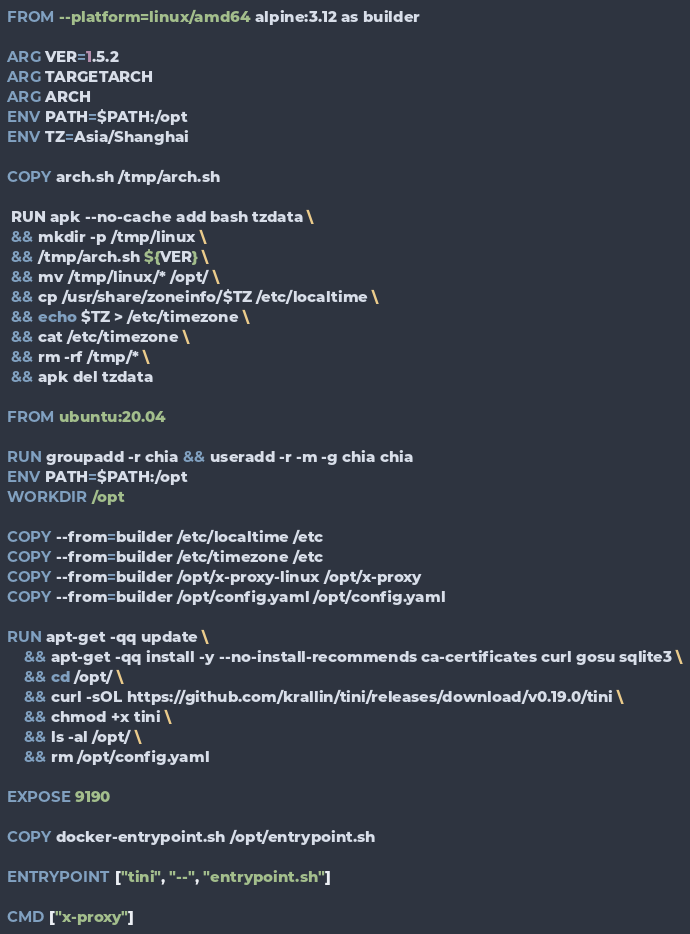Convert code to text. <code><loc_0><loc_0><loc_500><loc_500><_Dockerfile_>FROM --platform=linux/amd64 alpine:3.12 as builder

ARG VER=1.5.2
ARG TARGETARCH
ARG ARCH
ENV PATH=$PATH:/opt
ENV TZ=Asia/Shanghai

COPY arch.sh /tmp/arch.sh

 RUN apk --no-cache add bash tzdata \
 && mkdir -p /tmp/linux \
 && /tmp/arch.sh ${VER} \
 && mv /tmp/linux/* /opt/ \
 && cp /usr/share/zoneinfo/$TZ /etc/localtime \
 && echo $TZ > /etc/timezone \
 && cat /etc/timezone \
 && rm -rf /tmp/* \
 && apk del tzdata

FROM ubuntu:20.04

RUN groupadd -r chia && useradd -r -m -g chia chia
ENV PATH=$PATH:/opt
WORKDIR /opt

COPY --from=builder /etc/localtime /etc
COPY --from=builder /etc/timezone /etc
COPY --from=builder /opt/x-proxy-linux /opt/x-proxy
COPY --from=builder /opt/config.yaml /opt/config.yaml

RUN apt-get -qq update \
    && apt-get -qq install -y --no-install-recommends ca-certificates curl gosu sqlite3 \
    && cd /opt/ \
    && curl -sOL https://github.com/krallin/tini/releases/download/v0.19.0/tini \
    && chmod +x tini \
    && ls -al /opt/ \
    && rm /opt/config.yaml

EXPOSE 9190

COPY docker-entrypoint.sh /opt/entrypoint.sh

ENTRYPOINT ["tini", "--", "entrypoint.sh"]

CMD ["x-proxy"]
</code> 